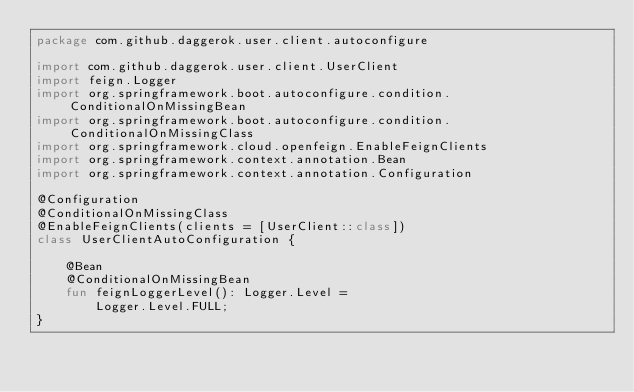<code> <loc_0><loc_0><loc_500><loc_500><_Kotlin_>package com.github.daggerok.user.client.autoconfigure

import com.github.daggerok.user.client.UserClient
import feign.Logger
import org.springframework.boot.autoconfigure.condition.ConditionalOnMissingBean
import org.springframework.boot.autoconfigure.condition.ConditionalOnMissingClass
import org.springframework.cloud.openfeign.EnableFeignClients
import org.springframework.context.annotation.Bean
import org.springframework.context.annotation.Configuration

@Configuration
@ConditionalOnMissingClass
@EnableFeignClients(clients = [UserClient::class])
class UserClientAutoConfiguration {

    @Bean
    @ConditionalOnMissingBean
    fun feignLoggerLevel(): Logger.Level =
        Logger.Level.FULL;
}
</code> 